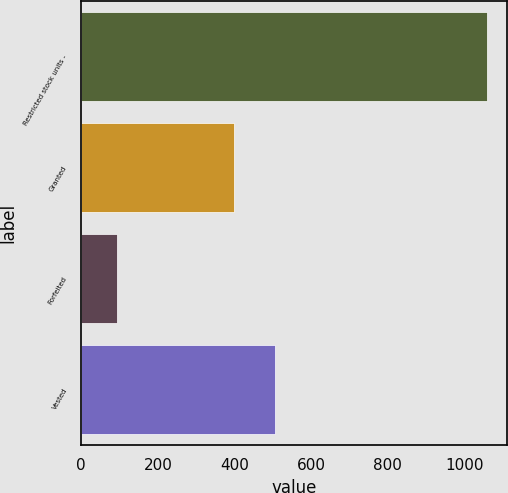<chart> <loc_0><loc_0><loc_500><loc_500><bar_chart><fcel>Restricted stock units -<fcel>Granted<fcel>Forfeited<fcel>Vested<nl><fcel>1060<fcel>399<fcel>93<fcel>506.7<nl></chart> 